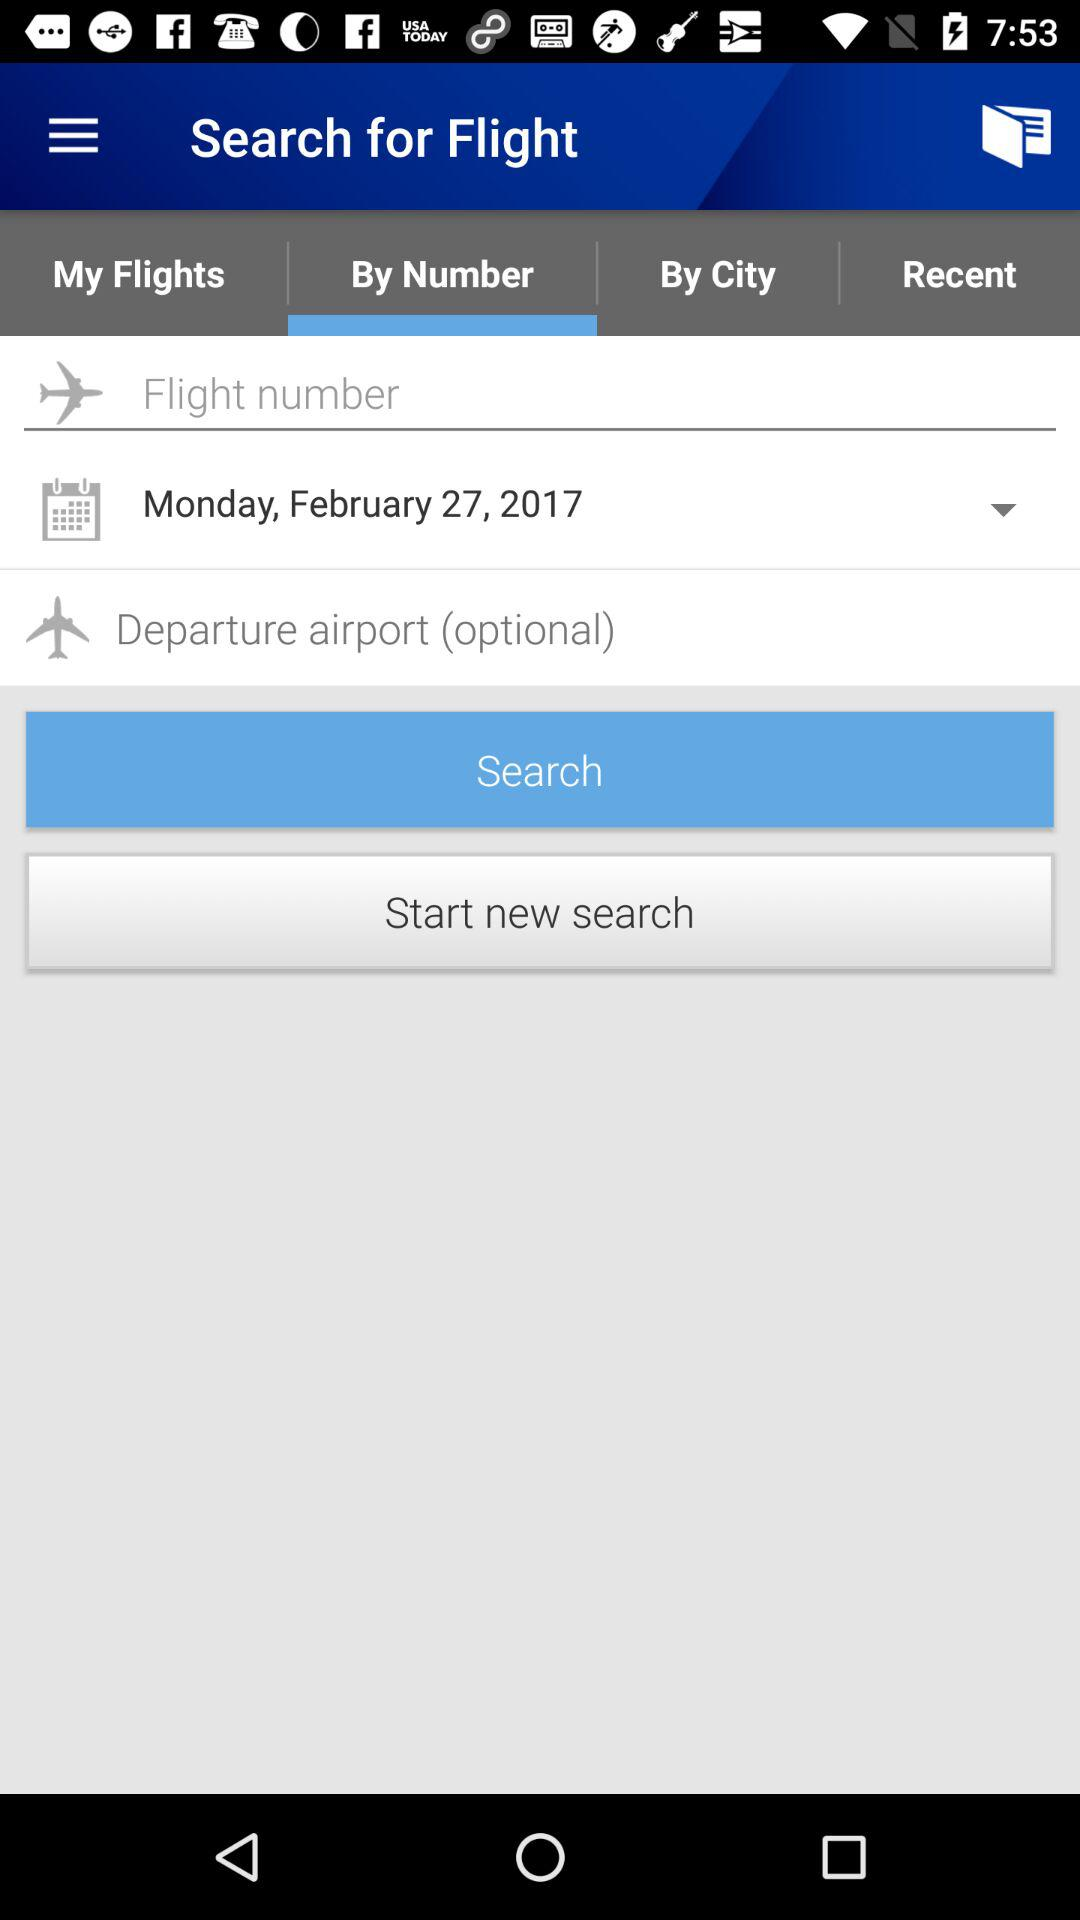Which option is selected in the menu bar? The selected option is "By Number". 